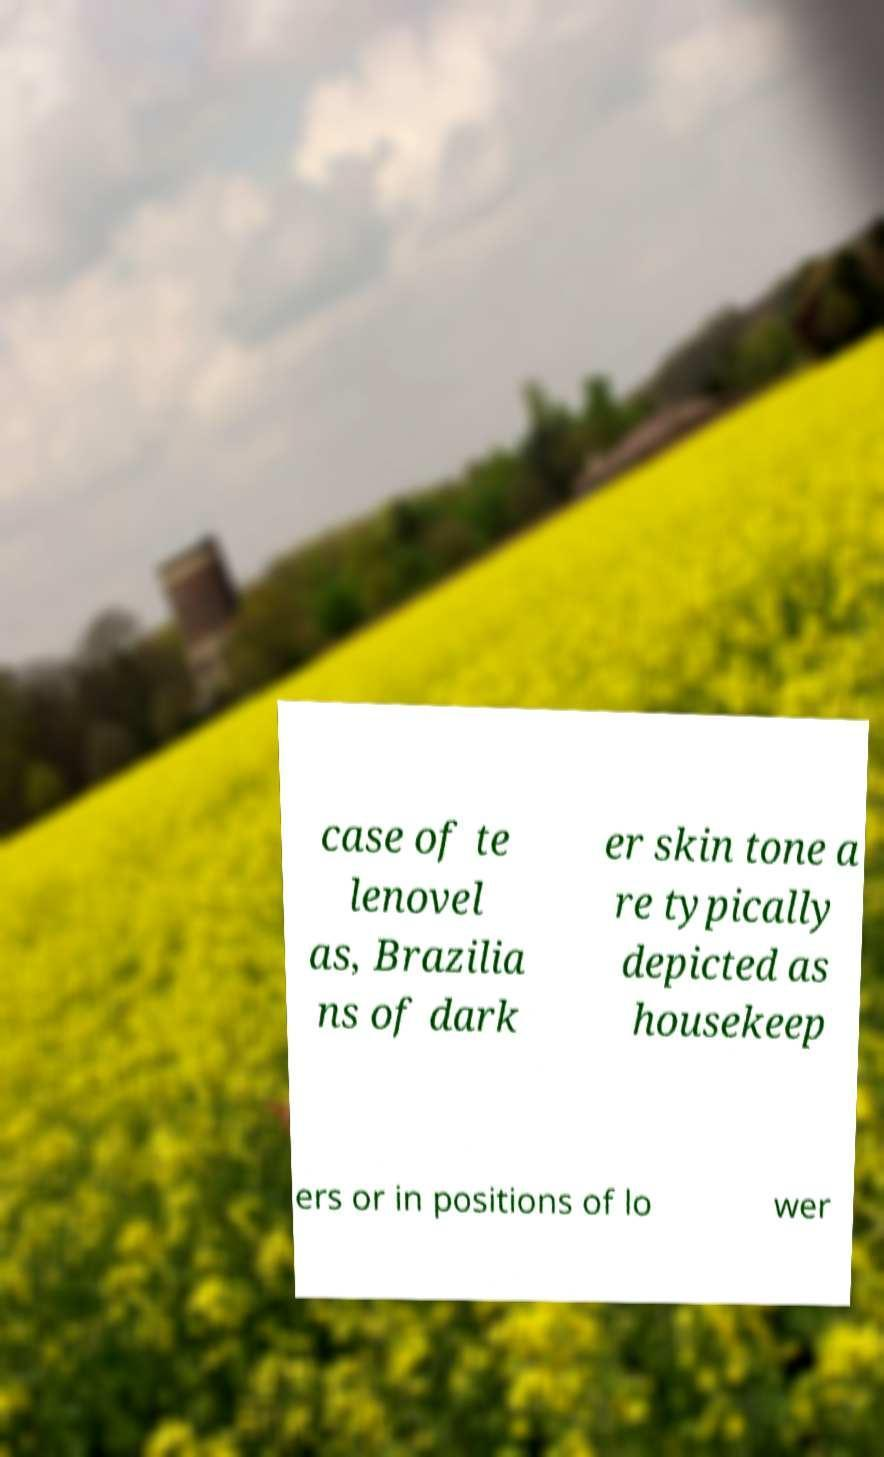There's text embedded in this image that I need extracted. Can you transcribe it verbatim? case of te lenovel as, Brazilia ns of dark er skin tone a re typically depicted as housekeep ers or in positions of lo wer 